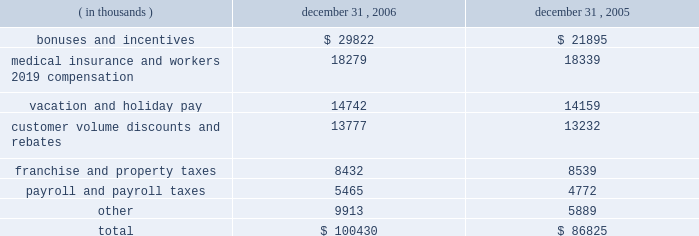Packaging corporation of america notes to consolidated financial statements ( continued ) december 31 , 2006 4 .
Stock-based compensation ( continued ) as of december 31 , 2006 , there was $ 8330000 of total unrecognized compensation costs related to the restricted stock awards .
The company expects to recognize the cost of these stock awards over a weighted-average period of 2.5 years .
Accrued liabilities the components of accrued liabilities are as follows: .
Employee benefit plans and other postretirement benefits in connection with the acquisition from pactiv , pca and pactiv entered into a human resources agreement which , among other items , granted pca employees continued participation in the pactiv pension plan for a period of up to five years following the closing of the acquisition for an agreed upon fee .
Effective january 1 , 2003 , pca adopted a mirror-image pension plan for eligible hourly employees to succeed the pactiv pension plan in which pca hourly employees had participated though december 31 , 2002 .
The pca pension plan for hourly employees recognizes service earned under both the pca plan and the prior pactiv plan .
Benefits earned under the pca plan are reduced by retirement benefits earned under the pactiv plan through december 31 , 2002 .
All assets and liabilities associated with benefits earned through december 31 , 2002 for hourly employees and retirees of pca were retained by the pactiv plan .
Effective may 1 , 2004 , pca adopted a grandfathered pension plan for certain salaried employees who had previously participated in the pactiv pension plan pursuant to the above mentioned human resource agreement .
The benefit formula for the new pca pension plan for salaried employees is comparable to that of the pactiv plan except that the pca plan uses career average base pay in the benefit formula in lieu of final average base pay .
The pca pension plan for salaried employees recognizes service earned under both the pca plan and the prior pactiv plan .
Benefits earned under the pca plan are reduced by retirement benefits earned under the pactiv plan through april 30 , 2004 .
All assets and liabilities associated with benefits earned through april 30 , 2004 for salaried employees and retirees of pca were retained by the pactiv plan .
Pca maintains a supplemental executive retirement plan ( 201cserp 201d ) , which augments pension benefits for eligible executives ( excluding the ceo ) earned under the pca pension plan for salaried employees .
Benefits are determined using the same formula as the pca pension plan but in addition to counting .
As of december 312006 what was the expected annual unrecognized compensation to be recognized in the future periods? 
Rationale: the company expects to recognize 3332000 from the total unrecognized compensation costs
Computations: (8330000 / 2.5)
Answer: 3332000.0. 